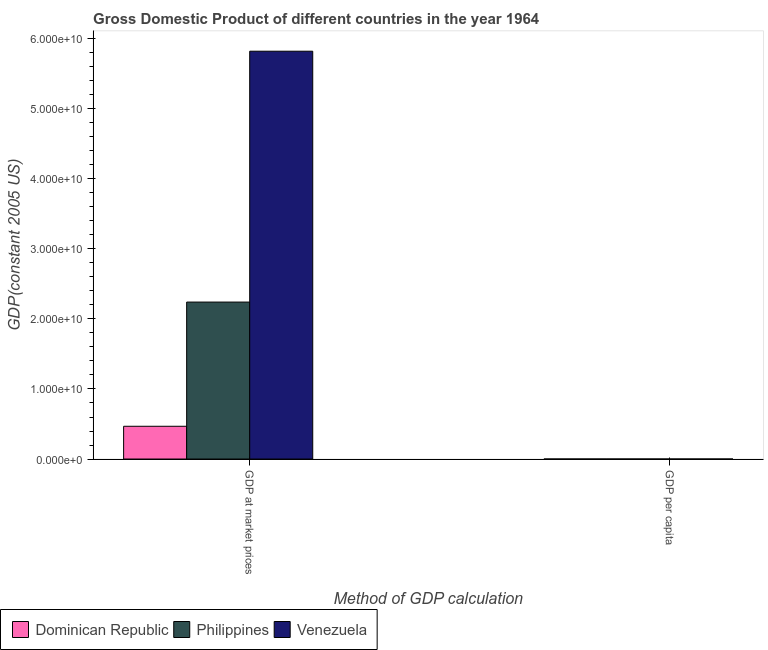How many different coloured bars are there?
Your answer should be compact. 3. Are the number of bars on each tick of the X-axis equal?
Provide a succinct answer. Yes. How many bars are there on the 1st tick from the left?
Your answer should be very brief. 3. How many bars are there on the 1st tick from the right?
Your answer should be very brief. 3. What is the label of the 1st group of bars from the left?
Provide a succinct answer. GDP at market prices. What is the gdp per capita in Dominican Republic?
Your response must be concise. 1244.71. Across all countries, what is the maximum gdp at market prices?
Make the answer very short. 5.82e+1. Across all countries, what is the minimum gdp at market prices?
Give a very brief answer. 4.68e+09. In which country was the gdp per capita maximum?
Offer a terse response. Venezuela. In which country was the gdp per capita minimum?
Offer a very short reply. Philippines. What is the total gdp per capita in the graph?
Your answer should be compact. 8137.09. What is the difference between the gdp per capita in Dominican Republic and that in Venezuela?
Ensure brevity in your answer.  -4899.73. What is the difference between the gdp per capita in Dominican Republic and the gdp at market prices in Philippines?
Provide a succinct answer. -2.24e+1. What is the average gdp at market prices per country?
Provide a succinct answer. 2.84e+1. What is the difference between the gdp at market prices and gdp per capita in Venezuela?
Your answer should be compact. 5.82e+1. In how many countries, is the gdp at market prices greater than 36000000000 US$?
Make the answer very short. 1. What is the ratio of the gdp at market prices in Dominican Republic to that in Philippines?
Keep it short and to the point. 0.21. What does the 3rd bar from the left in GDP per capita represents?
Your response must be concise. Venezuela. What does the 3rd bar from the right in GDP at market prices represents?
Provide a succinct answer. Dominican Republic. How many countries are there in the graph?
Offer a very short reply. 3. Does the graph contain any zero values?
Offer a very short reply. No. Where does the legend appear in the graph?
Offer a terse response. Bottom left. How are the legend labels stacked?
Ensure brevity in your answer.  Horizontal. What is the title of the graph?
Make the answer very short. Gross Domestic Product of different countries in the year 1964. Does "Kiribati" appear as one of the legend labels in the graph?
Provide a succinct answer. No. What is the label or title of the X-axis?
Make the answer very short. Method of GDP calculation. What is the label or title of the Y-axis?
Offer a very short reply. GDP(constant 2005 US). What is the GDP(constant 2005 US) in Dominican Republic in GDP at market prices?
Keep it short and to the point. 4.68e+09. What is the GDP(constant 2005 US) in Philippines in GDP at market prices?
Your response must be concise. 2.24e+1. What is the GDP(constant 2005 US) of Venezuela in GDP at market prices?
Provide a succinct answer. 5.82e+1. What is the GDP(constant 2005 US) in Dominican Republic in GDP per capita?
Offer a terse response. 1244.71. What is the GDP(constant 2005 US) in Philippines in GDP per capita?
Provide a short and direct response. 747.96. What is the GDP(constant 2005 US) in Venezuela in GDP per capita?
Provide a succinct answer. 6144.43. Across all Method of GDP calculation, what is the maximum GDP(constant 2005 US) of Dominican Republic?
Your answer should be very brief. 4.68e+09. Across all Method of GDP calculation, what is the maximum GDP(constant 2005 US) in Philippines?
Make the answer very short. 2.24e+1. Across all Method of GDP calculation, what is the maximum GDP(constant 2005 US) of Venezuela?
Keep it short and to the point. 5.82e+1. Across all Method of GDP calculation, what is the minimum GDP(constant 2005 US) in Dominican Republic?
Make the answer very short. 1244.71. Across all Method of GDP calculation, what is the minimum GDP(constant 2005 US) of Philippines?
Offer a very short reply. 747.96. Across all Method of GDP calculation, what is the minimum GDP(constant 2005 US) in Venezuela?
Ensure brevity in your answer.  6144.43. What is the total GDP(constant 2005 US) in Dominican Republic in the graph?
Ensure brevity in your answer.  4.68e+09. What is the total GDP(constant 2005 US) of Philippines in the graph?
Ensure brevity in your answer.  2.24e+1. What is the total GDP(constant 2005 US) in Venezuela in the graph?
Provide a short and direct response. 5.82e+1. What is the difference between the GDP(constant 2005 US) in Dominican Republic in GDP at market prices and that in GDP per capita?
Provide a succinct answer. 4.68e+09. What is the difference between the GDP(constant 2005 US) of Philippines in GDP at market prices and that in GDP per capita?
Your response must be concise. 2.24e+1. What is the difference between the GDP(constant 2005 US) of Venezuela in GDP at market prices and that in GDP per capita?
Your response must be concise. 5.82e+1. What is the difference between the GDP(constant 2005 US) in Dominican Republic in GDP at market prices and the GDP(constant 2005 US) in Philippines in GDP per capita?
Your answer should be compact. 4.68e+09. What is the difference between the GDP(constant 2005 US) in Dominican Republic in GDP at market prices and the GDP(constant 2005 US) in Venezuela in GDP per capita?
Give a very brief answer. 4.68e+09. What is the difference between the GDP(constant 2005 US) in Philippines in GDP at market prices and the GDP(constant 2005 US) in Venezuela in GDP per capita?
Your answer should be compact. 2.24e+1. What is the average GDP(constant 2005 US) in Dominican Republic per Method of GDP calculation?
Your answer should be compact. 2.34e+09. What is the average GDP(constant 2005 US) in Philippines per Method of GDP calculation?
Offer a very short reply. 1.12e+1. What is the average GDP(constant 2005 US) in Venezuela per Method of GDP calculation?
Provide a short and direct response. 2.91e+1. What is the difference between the GDP(constant 2005 US) of Dominican Republic and GDP(constant 2005 US) of Philippines in GDP at market prices?
Your answer should be compact. -1.77e+1. What is the difference between the GDP(constant 2005 US) of Dominican Republic and GDP(constant 2005 US) of Venezuela in GDP at market prices?
Offer a terse response. -5.35e+1. What is the difference between the GDP(constant 2005 US) of Philippines and GDP(constant 2005 US) of Venezuela in GDP at market prices?
Your response must be concise. -3.58e+1. What is the difference between the GDP(constant 2005 US) of Dominican Republic and GDP(constant 2005 US) of Philippines in GDP per capita?
Keep it short and to the point. 496.75. What is the difference between the GDP(constant 2005 US) in Dominican Republic and GDP(constant 2005 US) in Venezuela in GDP per capita?
Your answer should be very brief. -4899.73. What is the difference between the GDP(constant 2005 US) of Philippines and GDP(constant 2005 US) of Venezuela in GDP per capita?
Your answer should be very brief. -5396.47. What is the ratio of the GDP(constant 2005 US) in Dominican Republic in GDP at market prices to that in GDP per capita?
Keep it short and to the point. 3.76e+06. What is the ratio of the GDP(constant 2005 US) of Philippines in GDP at market prices to that in GDP per capita?
Offer a very short reply. 3.00e+07. What is the ratio of the GDP(constant 2005 US) in Venezuela in GDP at market prices to that in GDP per capita?
Your response must be concise. 9.48e+06. What is the difference between the highest and the second highest GDP(constant 2005 US) in Dominican Republic?
Your answer should be compact. 4.68e+09. What is the difference between the highest and the second highest GDP(constant 2005 US) of Philippines?
Give a very brief answer. 2.24e+1. What is the difference between the highest and the second highest GDP(constant 2005 US) in Venezuela?
Keep it short and to the point. 5.82e+1. What is the difference between the highest and the lowest GDP(constant 2005 US) of Dominican Republic?
Provide a succinct answer. 4.68e+09. What is the difference between the highest and the lowest GDP(constant 2005 US) in Philippines?
Provide a short and direct response. 2.24e+1. What is the difference between the highest and the lowest GDP(constant 2005 US) of Venezuela?
Give a very brief answer. 5.82e+1. 